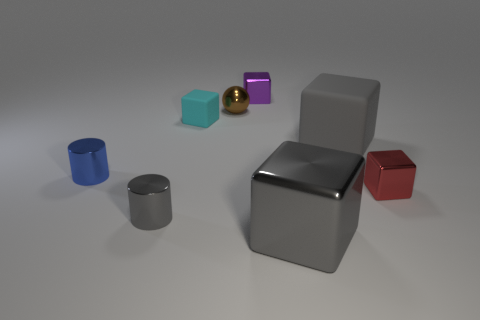What size is the brown metal thing?
Give a very brief answer. Small. There is a tiny cylinder that is the same color as the big matte object; what material is it?
Your response must be concise. Metal. How many large metallic things have the same color as the big matte object?
Provide a short and direct response. 1. Is the size of the purple shiny cube the same as the blue metallic thing?
Make the answer very short. Yes. There is a gray cube that is behind the metallic object that is on the right side of the large metallic cube; what is its size?
Make the answer very short. Large. Is the color of the shiny ball the same as the metal cylinder that is in front of the tiny blue object?
Ensure brevity in your answer.  No. Are there any cubes that have the same size as the gray metallic cylinder?
Make the answer very short. Yes. How big is the object in front of the small gray shiny cylinder?
Ensure brevity in your answer.  Large. Is there a big gray rubber block that is in front of the big gray thing that is in front of the gray metallic cylinder?
Your answer should be compact. No. How many other objects are the same shape as the small gray object?
Provide a succinct answer. 1. 